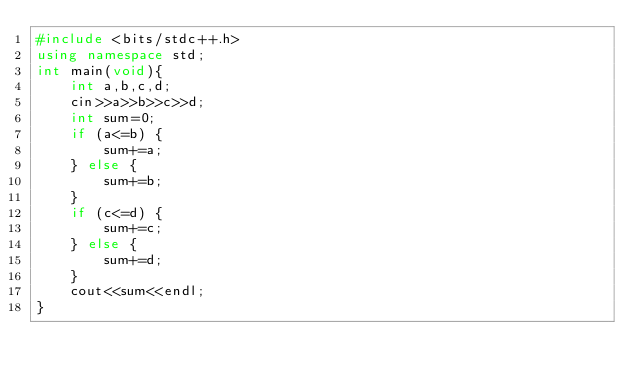Convert code to text. <code><loc_0><loc_0><loc_500><loc_500><_C++_>#include <bits/stdc++.h>
using namespace std;
int main(void){
    int a,b,c,d;
    cin>>a>>b>>c>>d;
    int sum=0;
    if (a<=b) {
        sum+=a;
    } else {
        sum+=b;
    }
    if (c<=d) {
        sum+=c;
    } else {
        sum+=d;
    }
    cout<<sum<<endl;
}
</code> 